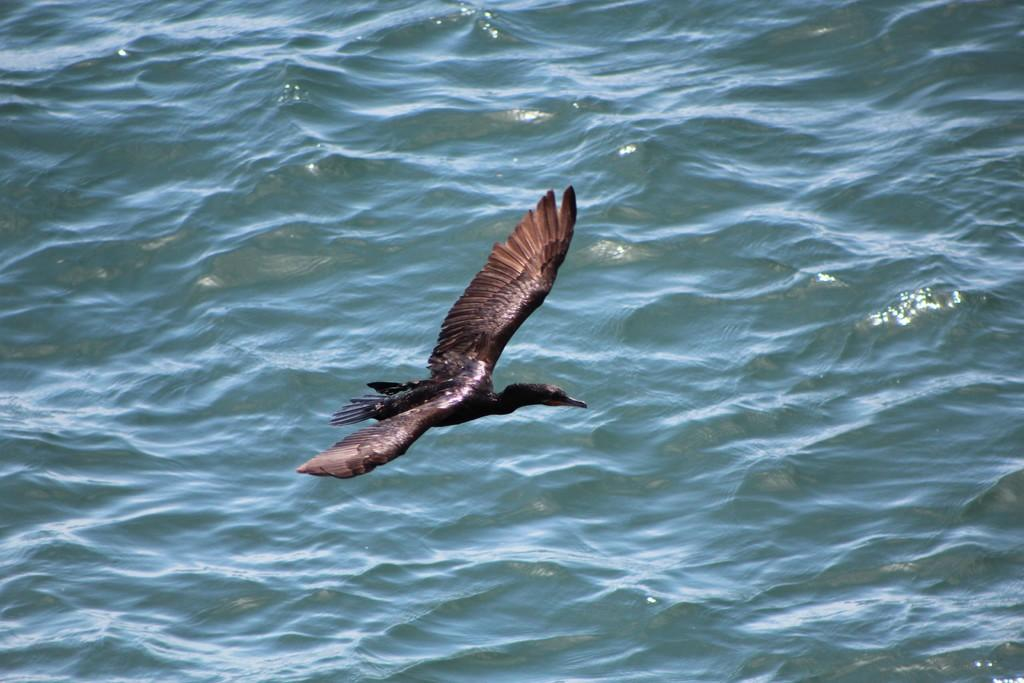What is the main subject of the image? The main subject of the image is a bird flying. What can be seen in the background of the image? There is water visible in the background of the image. How many toes does the bird have in the image? The number of toes on the bird cannot be determined from the image. Where is the lunchroom located in the image? There is no lunchroom present in the image. 